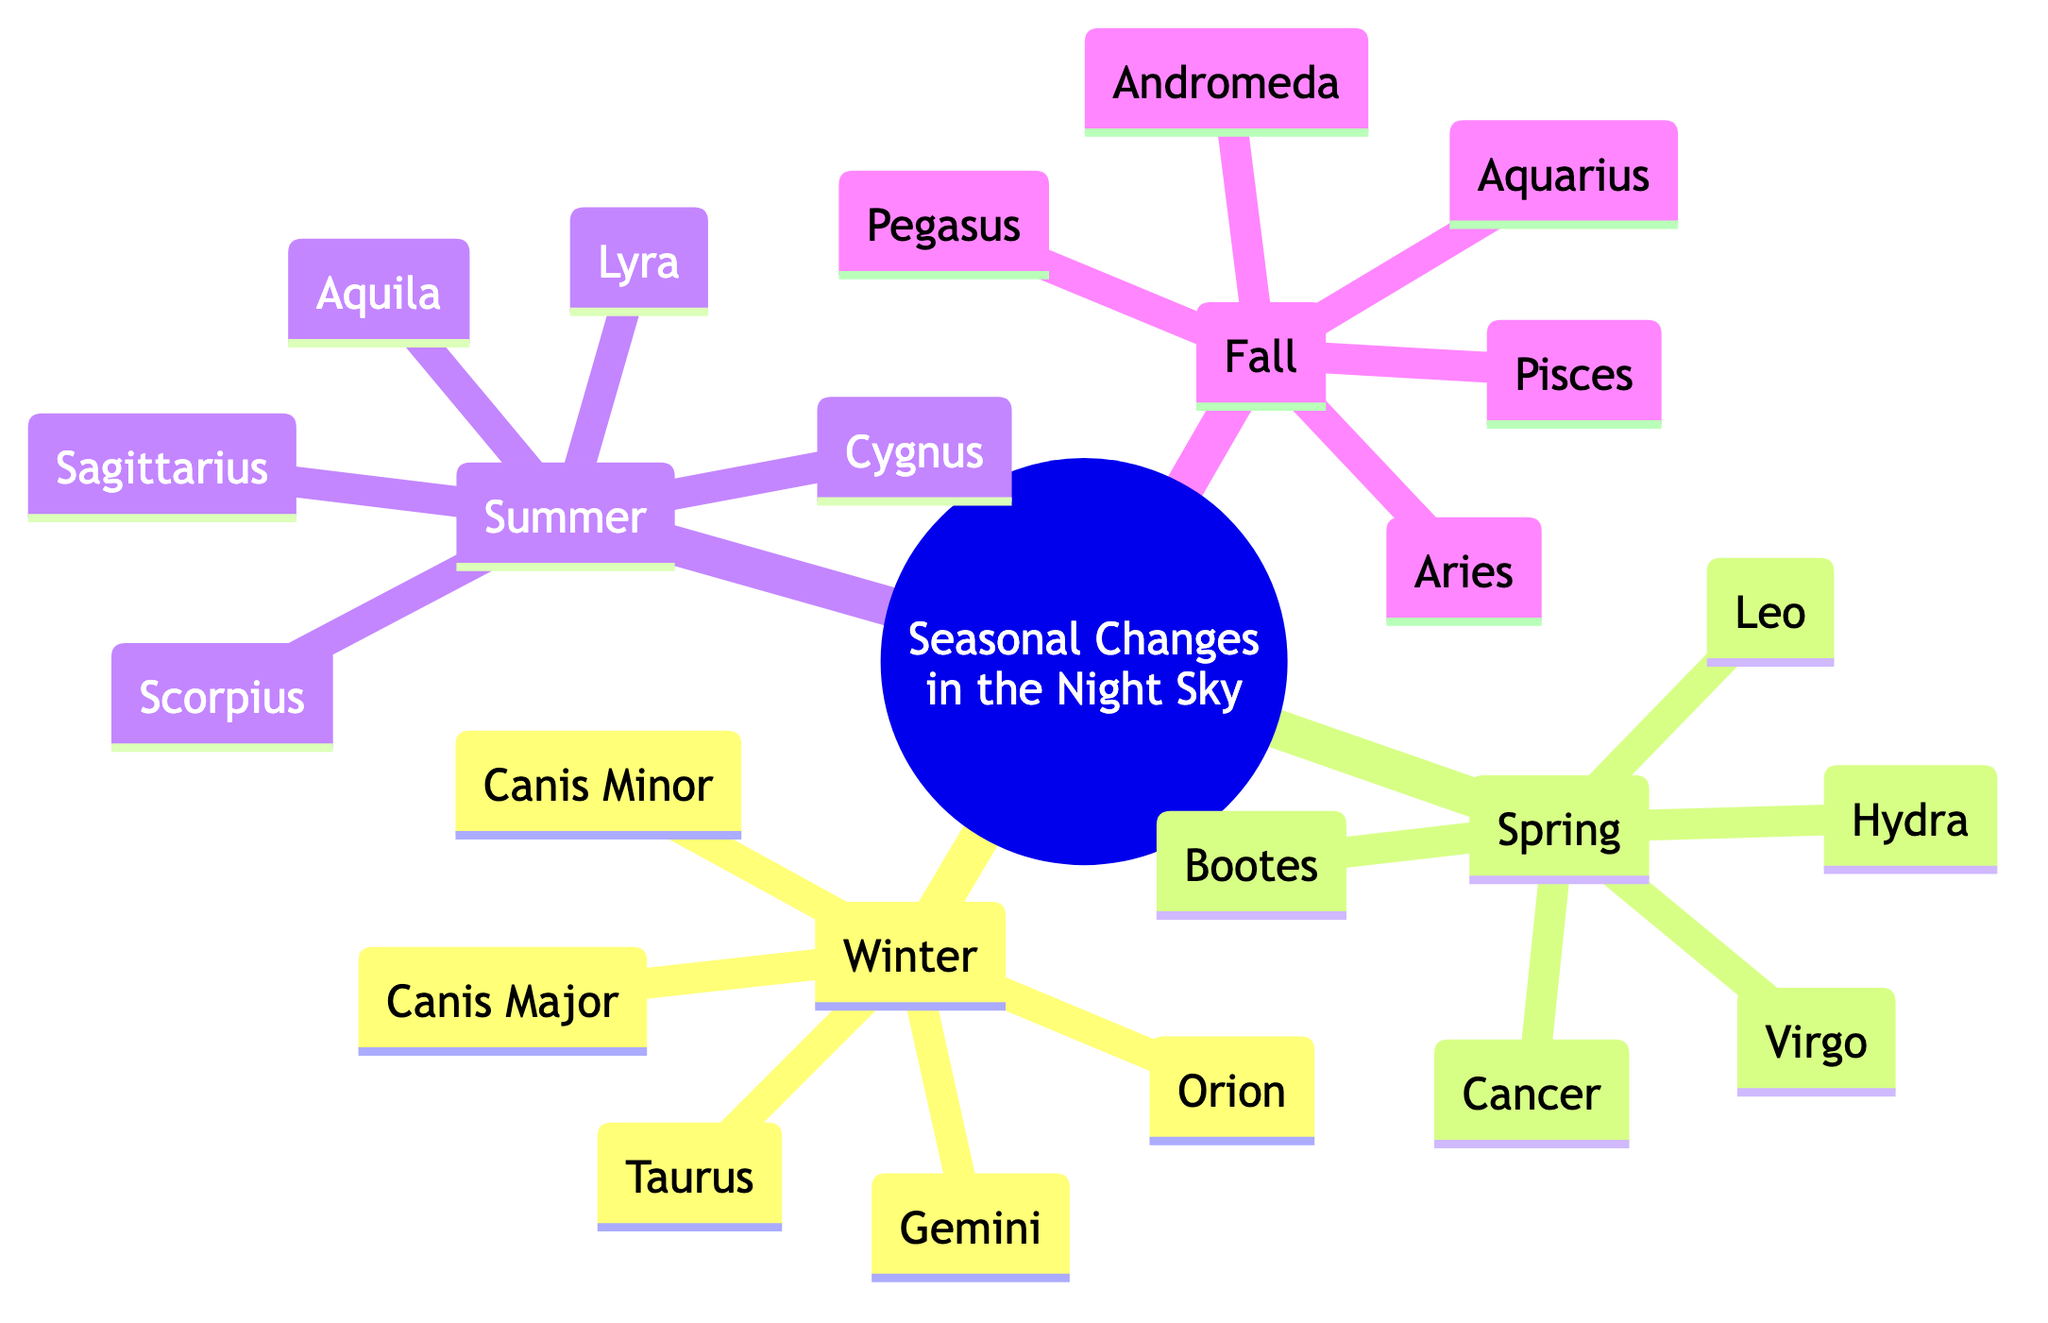What are the major constellations in Winter? In the diagram, under the "Winter" section, the major constellations listed are Orion, Taurus, Gemini, Canis Major, and Canis Minor.
Answer: Orion, Taurus, Gemini, Canis Major, Canis Minor How many major constellations are shown for Fall? The "Fall" section lists five major constellations: Pegasus, Andromeda, Pisces, Aries, and Aquarius. To find the total, we simply count them.
Answer: 5 Which constellation is listed first for Spring? The first constellation under the "Spring" section is Leo. By reading down the list in that section, Leo is found at the top.
Answer: Leo Name a constellation visible in Summer. In the "Summer" section, constellations include Cygnus, Lyra, Aquila, Scorpius, and Sagittarius. Any of these will suffice as the answer.
Answer: Cygnus Are there more constellations listed for Spring or Winter? Winter has five constellations (Orion, Taurus, Gemini, Canis Major, Canis Minor) and Spring also has five (Leo, Virgo, Bootes, Hydra, Cancer). Since both have the same number, we compare them directly.
Answer: Same number What is the second constellation listed for Winter? The second constellation under the "Winter" section is Taurus. By looking at the list, we find Taurus follows Orion in the sequence.
Answer: Taurus Which two seasons do not have the constellation Virgo? By examining the lists for all four seasons, Virgo is present in Spring and does not appear in Winter, Summer, or Fall. Thus, Winter and Fall are the answers.
Answer: Winter, Fall Identify one constellation that appears in both Summer and Fall. Looking at the lists, only the distinct constellations are shown in each season. Summer has Cygnus, Lyra, Aquila, Scorpius, Sagittarius; Fall has Pegasus, Andromeda, Pisces, Aries, Aquarius, so there are no overlapping constellations.
Answer: None Name all the major constellations visible in the night sky during Fall. In the diagram, the "Fall" section contains Pegasus, Andromeda, Pisces, Aries, and Aquarius. By referring to this section, we can easily list them.
Answer: Pegasus, Andromeda, Pisces, Aries, Aquarius 